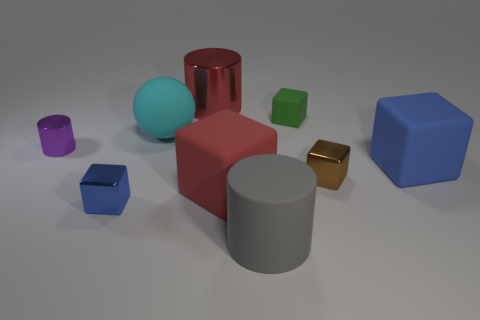How many blue cubes must be subtracted to get 1 blue cubes? 1 Subtract 2 blocks. How many blocks are left? 3 Subtract all large red rubber cubes. How many cubes are left? 4 Subtract all brown cubes. How many cubes are left? 4 Subtract all gray cubes. Subtract all yellow spheres. How many cubes are left? 5 Subtract all balls. How many objects are left? 8 Subtract 0 gray spheres. How many objects are left? 9 Subtract all purple metal things. Subtract all big gray rubber things. How many objects are left? 7 Add 9 tiny green rubber cubes. How many tiny green rubber cubes are left? 10 Add 5 big gray rubber cylinders. How many big gray rubber cylinders exist? 6 